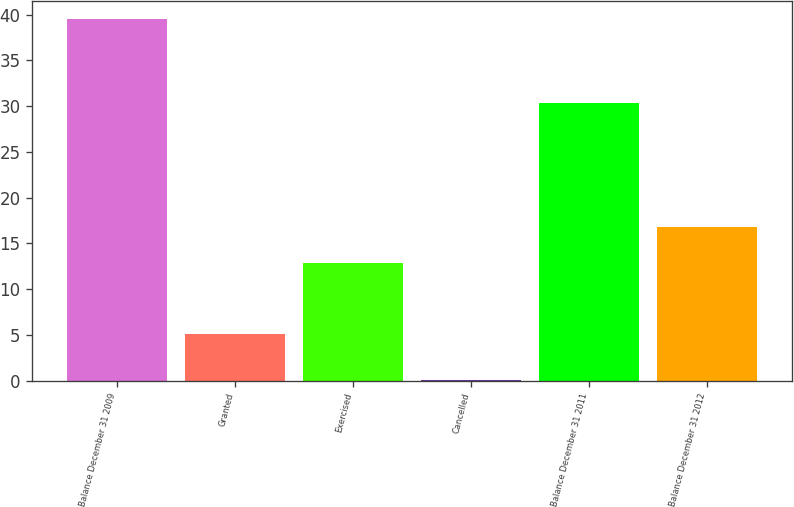Convert chart. <chart><loc_0><loc_0><loc_500><loc_500><bar_chart><fcel>Balance December 31 2009<fcel>Granted<fcel>Exercised<fcel>Cancelled<fcel>Balance December 31 2011<fcel>Balance December 31 2012<nl><fcel>39.5<fcel>5.1<fcel>12.9<fcel>0.1<fcel>30.4<fcel>16.84<nl></chart> 